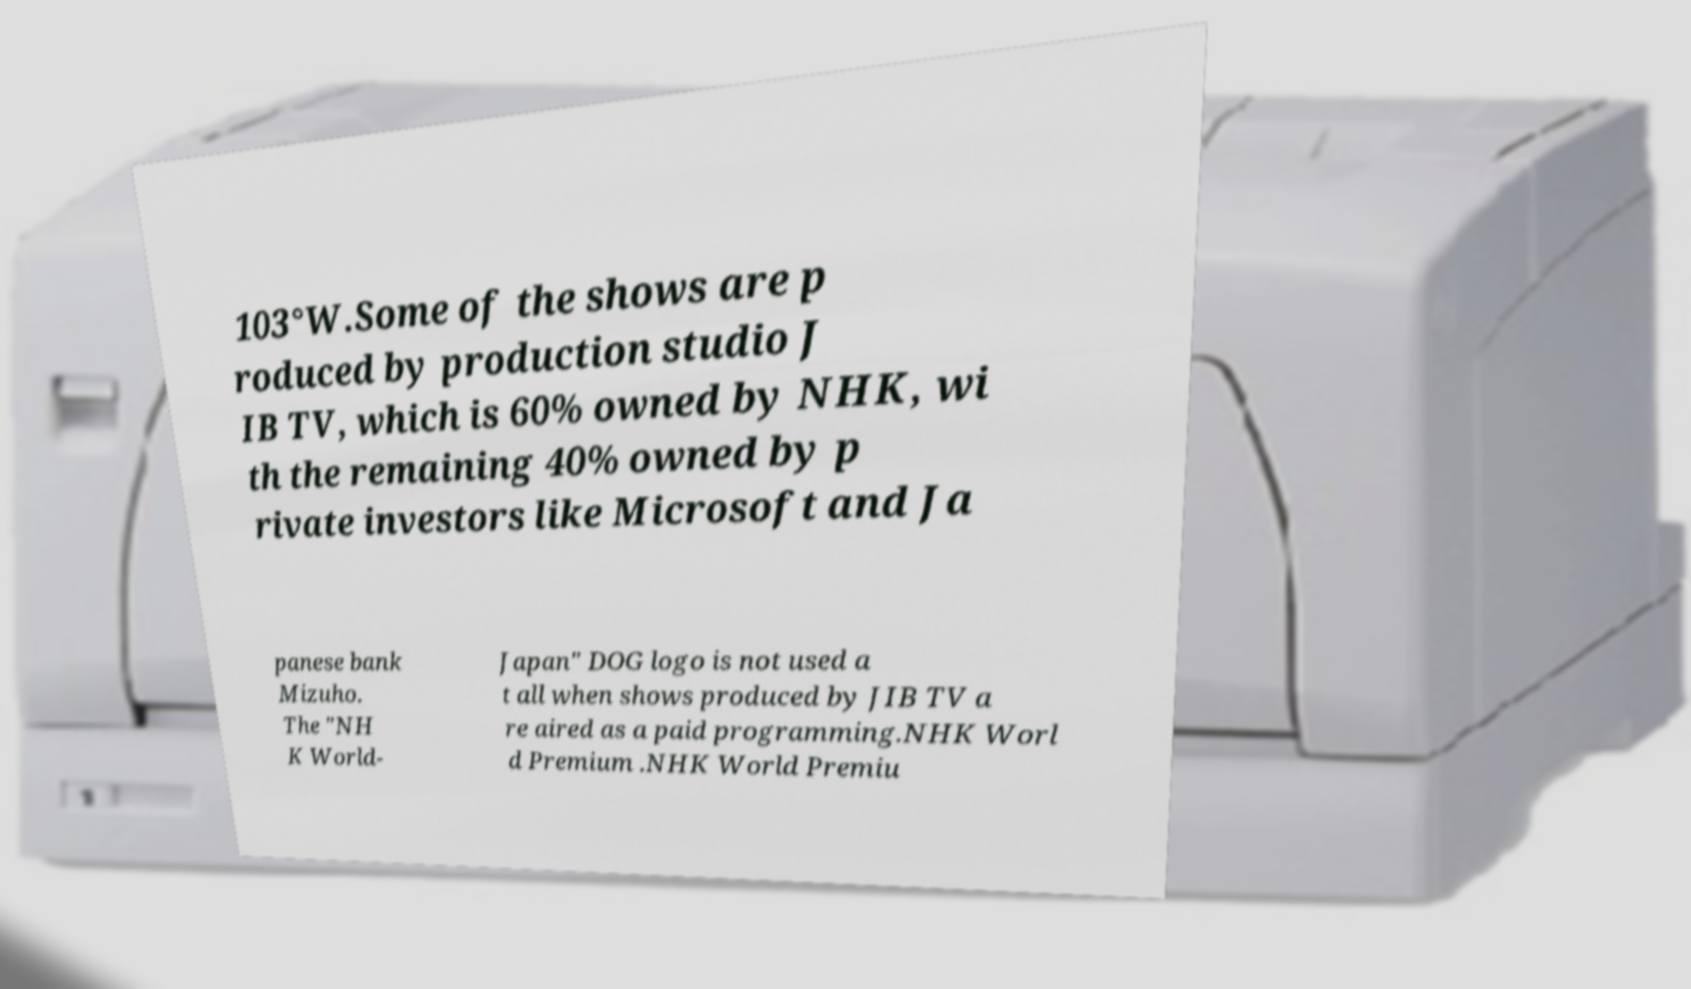Please read and relay the text visible in this image. What does it say? 103°W.Some of the shows are p roduced by production studio J IB TV, which is 60% owned by NHK, wi th the remaining 40% owned by p rivate investors like Microsoft and Ja panese bank Mizuho. The "NH K World- Japan" DOG logo is not used a t all when shows produced by JIB TV a re aired as a paid programming.NHK Worl d Premium .NHK World Premiu 